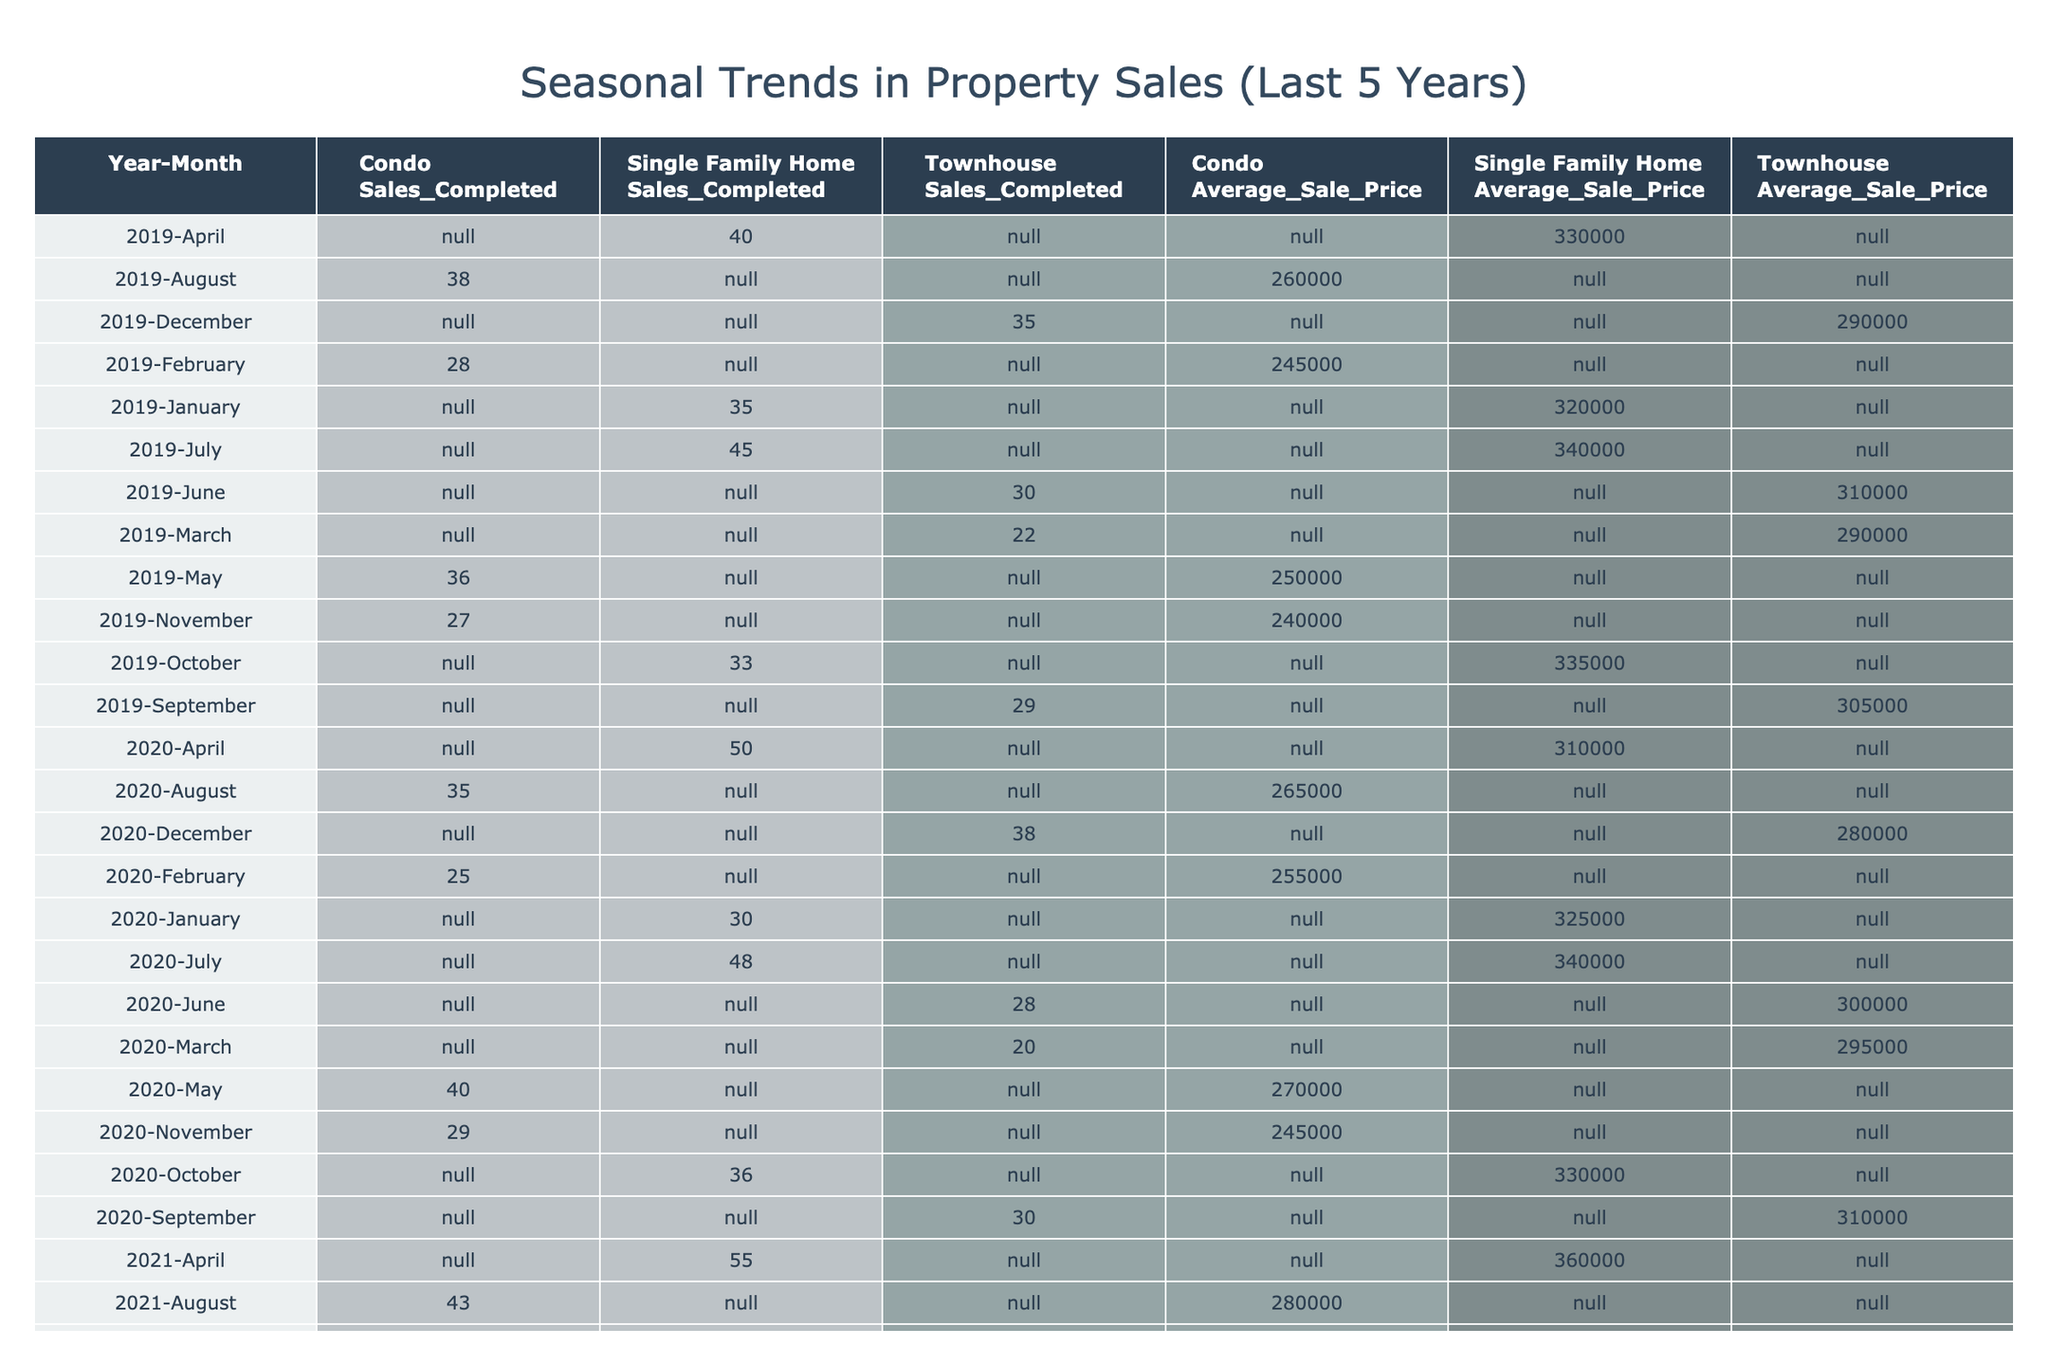What was the highest number of single-family home sales in a single month over the last five years? Looking through the table specifically for 'Single Family Home' sales, the highest values are in July 2021 and July 2022, both with 60 and 55 sales respectively. Hence, the highest month is July 2021 with 60 sales.
Answer: 60 In which month did condo sales have the lowest recorded average sale price? The table shows that the average sale price of condos is lowest in November 2020 at 245,000. This is determined by reviewing all 'Condo Average Sale Price' values in the table and identifying the minimum.
Answer: 245000 What is the total number of townhouse sales completed in 2022? By extracting the sales completed for 'Townhouse' from each month in 2022 (27 + 30 + 34 + 31 + 36 + 42), we calculate the total to be 200.
Answer: 200 Did the average sale price of single-family homes increase or decrease from 2021 to 2022? Comparing the average sale prices of single-family homes for those two years: 2021 has averages of 350,000 in January and 375,000 in July, while 2022 has averages of 340,000 in January and 375,000 in July. Since both started at lower than 2021's starting price and the ending prices match, the conclusion is that the overall trend showed a decrease initially.
Answer: Decrease What is the average number of condo sales completed from 2020 to 2023? To find this, we add the condo sales completed over these four years (25 + 29 + 30 + 33) and then divide by 4 to find the average. The calculations yield a total of 117, divided by 4 giving an average of 29.25 which rounds to 29.
Answer: 29 Which property type saw the largest fluctuation in sales completed over the five-year period? By analyzing the sales completed across all property types year by year, 'Single Family Home' sales peaked at 60 in July 2021 and decreased to 39 in January 2023, showing a fluctuation of 21 sales. Other property types like condos and townhouses show less variance in comparison.
Answer: Single Family Home How many more townhouse sales were completed in 2023 compared to 2021? Checking the sales completed shows 36 in September 2023 and 36 in September 2021. We find that 2023 totals 41 and 2021 totals 39, thus 41 - 39 equals an increase of 2 sales in that span.
Answer: 2 Is it true that average sale prices for townhouses increased from 2020 to 2023? By comparing the average sale prices for townhouses in both years (280,000 in December 2020 and 305,000 in December 2023), we find that the average indeed increased from 280,000 to 305,000, confirming the statement as true.
Answer: True 